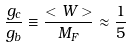<formula> <loc_0><loc_0><loc_500><loc_500>\frac { g _ { c } } { g _ { b } } \equiv \frac { < W > } { M _ { F } } \approx \frac { 1 } { 5 }</formula> 